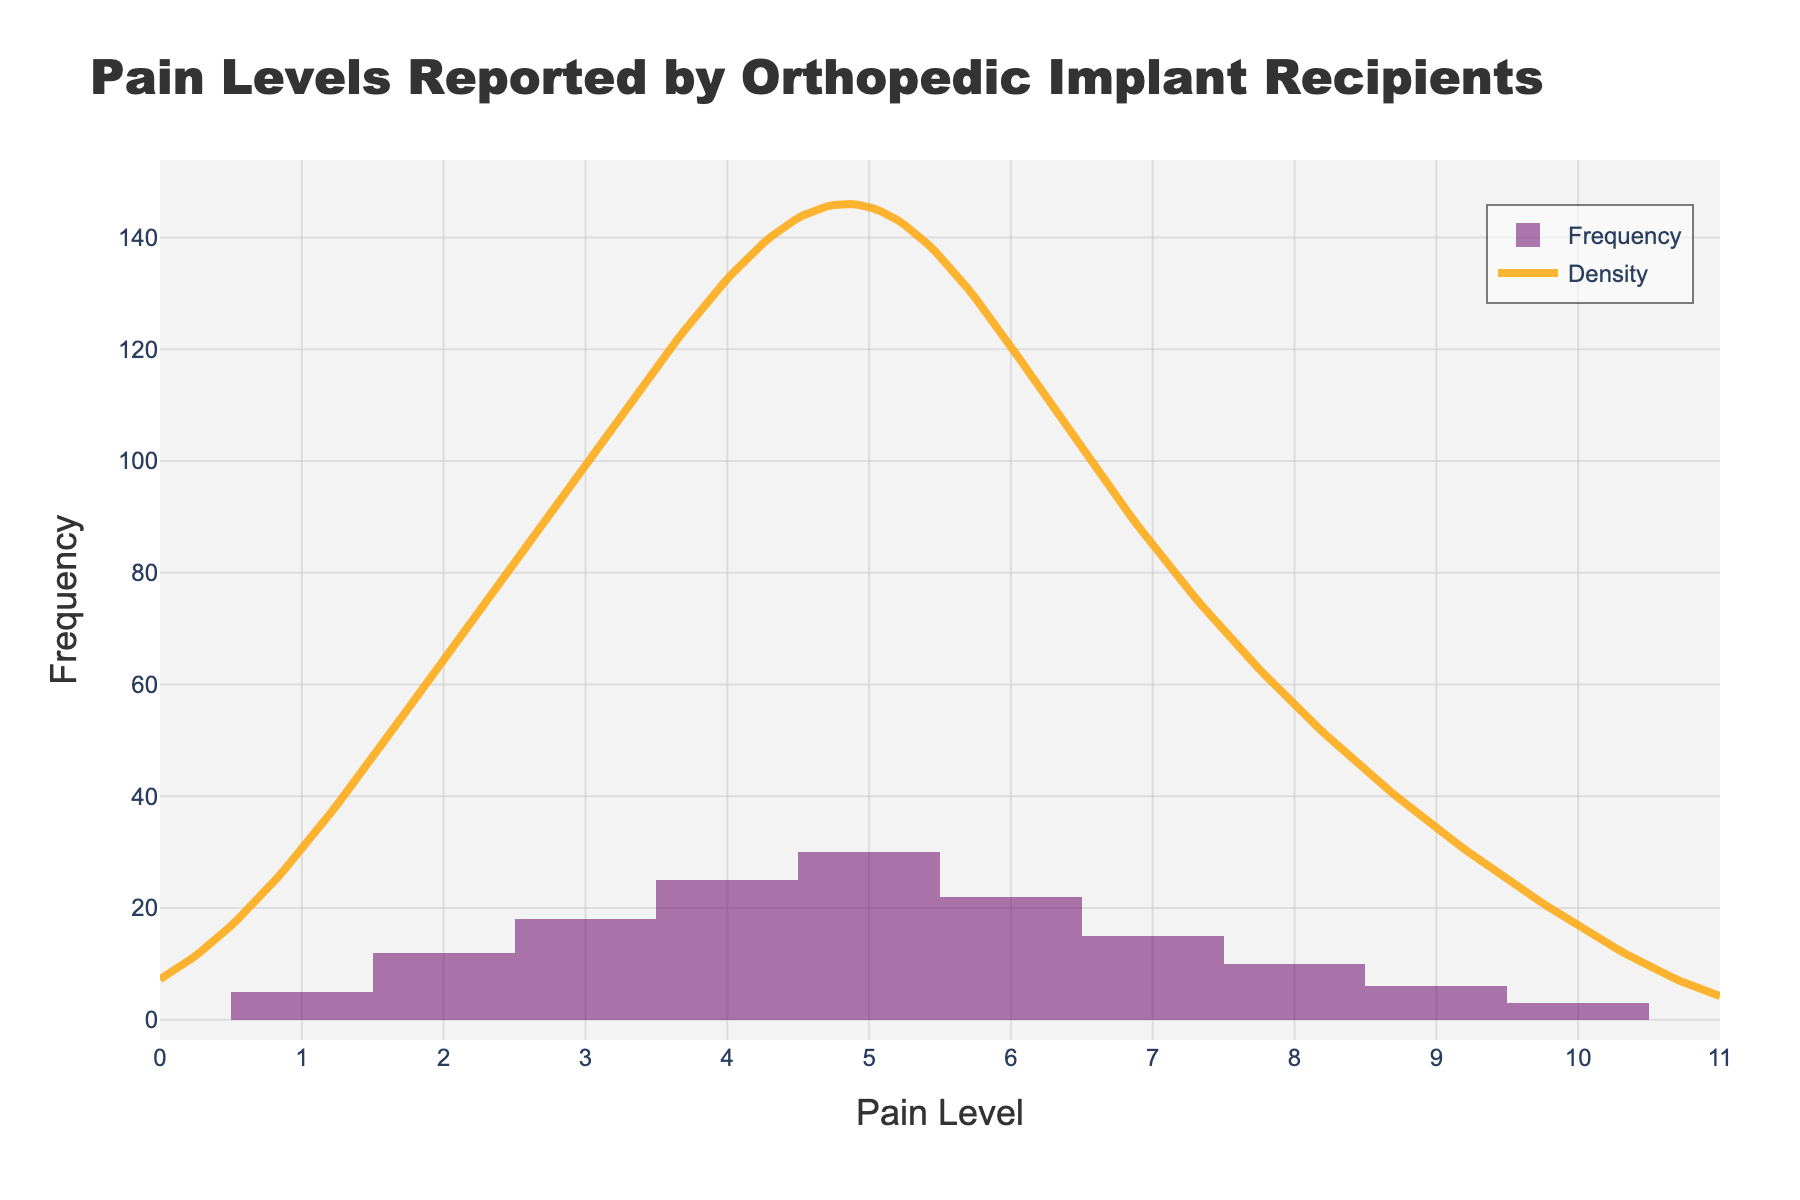what is the title of the figure? The title is located at the top center of the figure and clearly indicates the subject of the chart. It reads, "Pain Levels Reported by Orthopedic Implant Recipients."
Answer: Pain Levels Reported by Orthopedic Implant Recipients What is the range of pain levels on the x-axis? The x-axis shows the range of pain levels listed at the bottom of the chart. It spans from 0 to 11.
Answer: 0 to 11 Which pain level has the highest frequency? By examining the tallest bar in the histogram, we can see which pain level it corresponds to. The tallest bar is at pain level 5.
Answer: 5 How many pain levels have a frequency higher than 20? Observing the heights of the bars, we identify which ones exceed a y-value of 20. Pain levels 4, 5, and 6 meet this criteria.
Answer: 3 What is the frequency of the pain level with the lowest reported occurrences? The shortest bar in the histogram represents the lowest frequency. Pain level 10 has the lowest frequency of 3.
Answer: 3 Between which two pain levels is there the steepest drop in frequency? Comparing the heights of adjacent bars to see where the drop in frequency is the most pronounced, the steepest drop is between pain levels 5 and 6.
Answer: Between 5 and 6 Is the density curve peak the same as the histogram's highest frequency bar? By looking at both the tallest bar in the histogram and the peak of the KDE (density curve), we can see if they align. The KDE peak and the tall bar both correspond to pain level 5.
Answer: Yes What is the shape of the density curve between pain levels 3 and 6? Observing the KDE line in this section, notice its form. It rises smoothly, peaks at 5, and then descends, showing a classic bell curve.
Answer: Bell-shaped Does the histogram show symmetry? By checking if the bars are symmetric around a central point, we can assess symmetry. The histogram is not symmetric as it is skewed towards higher pain levels.
Answer: No What is the average frequency of the pain levels from 1 to 10? Adding the frequencies of these pain levels and then dividing by the number of levels calculates the average. Sum: 5 + 12 + 18 + 25 + 30 + 22 + 15 + 10 + 6 + 3 = 146. Average = 146 / 10 = 14.6.
Answer: 14.6 